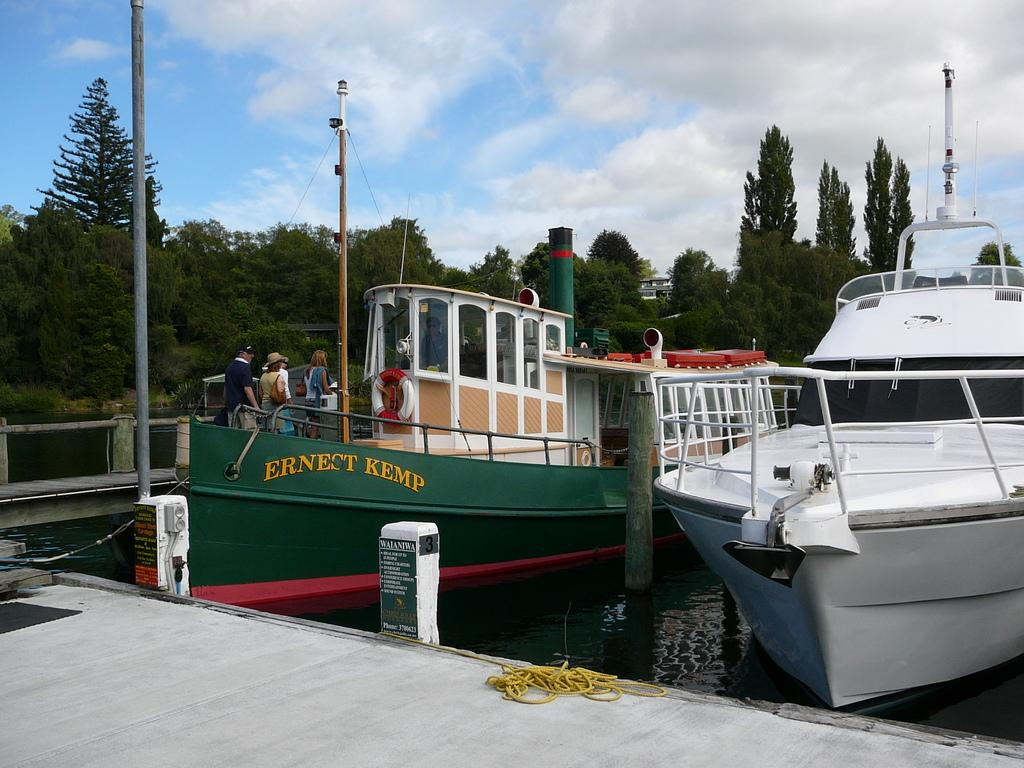What type of surface is visible in the image? There is a wooden surface in the image. What can be seen on the wooden surface? There are two ships in the image. Are there any people on the ships? Yes, there are people on the first ship. What is the surrounding environment like in the image? There are many trees around the ships. What type of sofa can be seen on the second ship in the image? There is no sofa present on either ship in the image. 